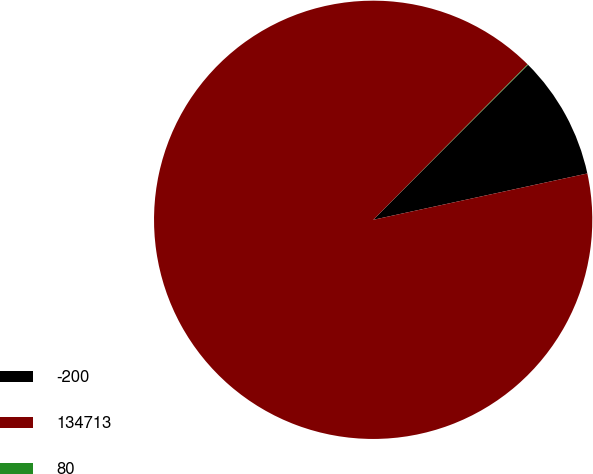Convert chart. <chart><loc_0><loc_0><loc_500><loc_500><pie_chart><fcel>-200<fcel>134713<fcel>80<nl><fcel>9.12%<fcel>90.85%<fcel>0.04%<nl></chart> 